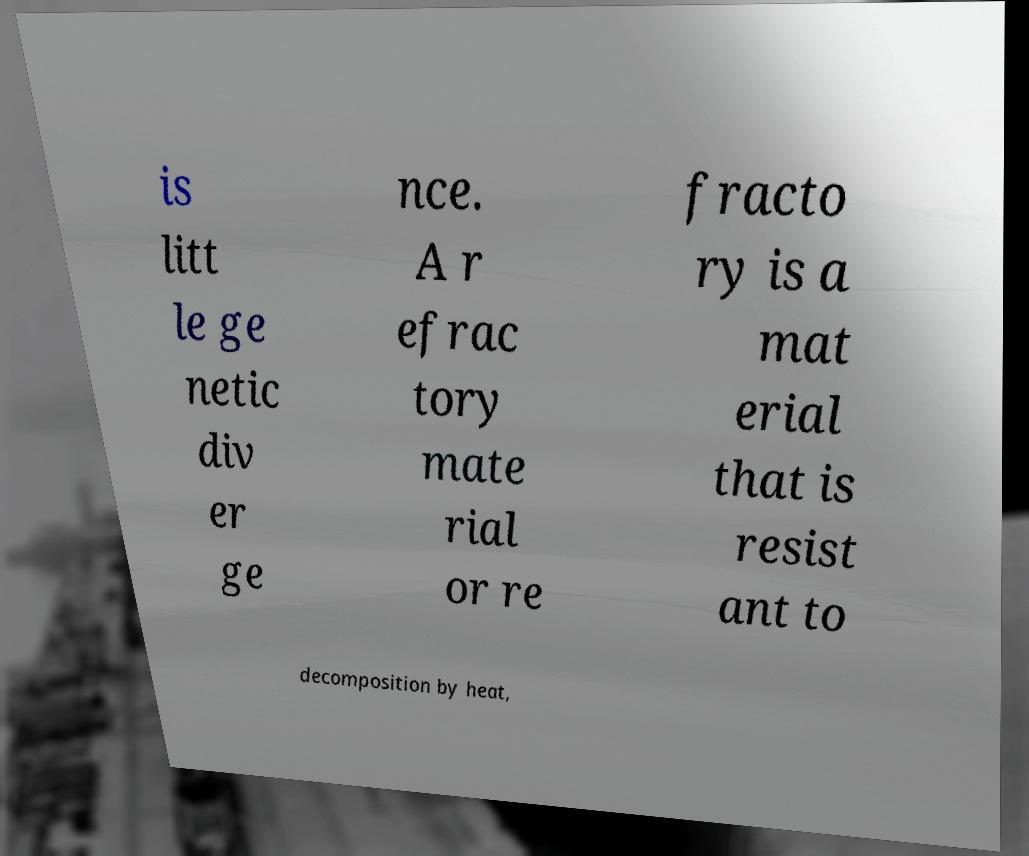Can you accurately transcribe the text from the provided image for me? is litt le ge netic div er ge nce. A r efrac tory mate rial or re fracto ry is a mat erial that is resist ant to decomposition by heat, 